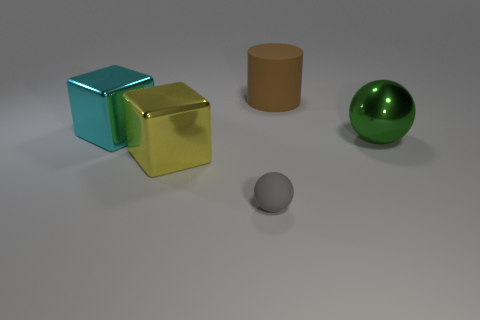Are there any other things that have the same size as the gray matte sphere?
Provide a succinct answer. No. Is the big yellow metal thing the same shape as the brown object?
Make the answer very short. No. There is a small rubber object; are there any large cyan objects to the right of it?
Offer a very short reply. No. What number of things are large yellow shiny balls or cyan metallic things?
Make the answer very short. 1. What number of other objects are there of the same size as the green shiny sphere?
Provide a short and direct response. 3. What number of big objects are both in front of the cyan cube and behind the large cyan block?
Ensure brevity in your answer.  0. There is a metallic cube that is on the right side of the cyan cube; is it the same size as the rubber thing that is in front of the big green ball?
Keep it short and to the point. No. There is a cube behind the metallic sphere; what is its size?
Your answer should be very brief. Large. How many things are big metal objects that are on the left side of the yellow metallic block or things that are right of the tiny rubber sphere?
Make the answer very short. 3. Are there the same number of gray balls that are on the left side of the large yellow thing and big green things behind the gray matte thing?
Your answer should be very brief. No. 